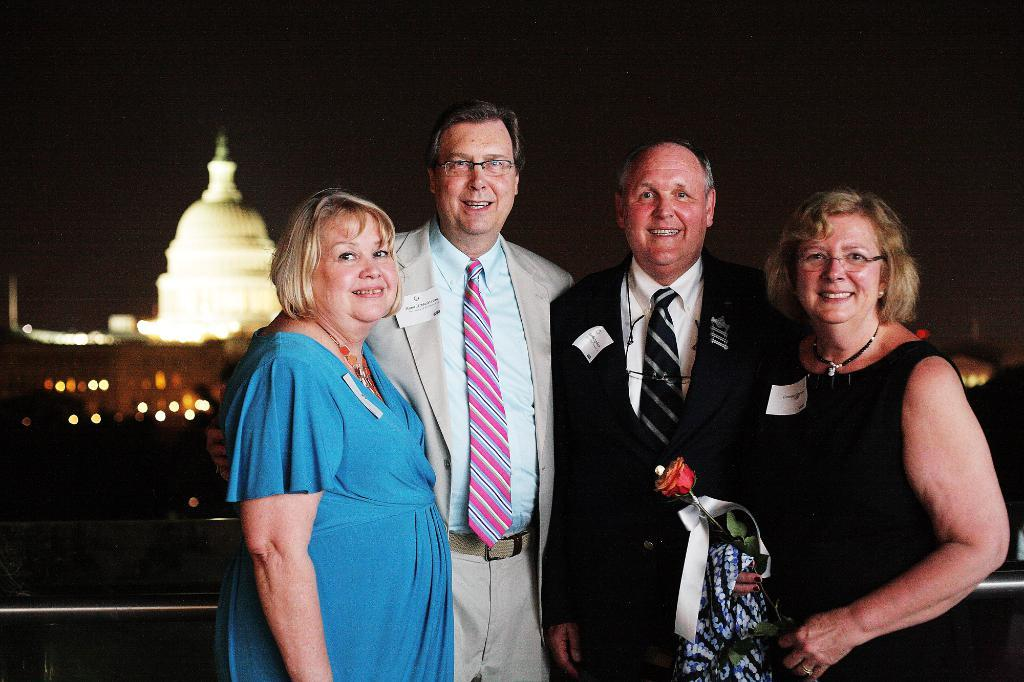What type of people can be seen in the image? There is a group of old men and women in the image. Where are the people in the image located? The group is standing in the front. What is the facial expression of the people in the image? The people in the group are smiling. What are the people in the image doing? The group is giving a pose into the camera. What can be seen in the background of the image? There is a white dome building in the background of the image. What type of steel is used to construct the meal in the image? There is no meal present in the image, and therefore no steel is not relevant to the image. 